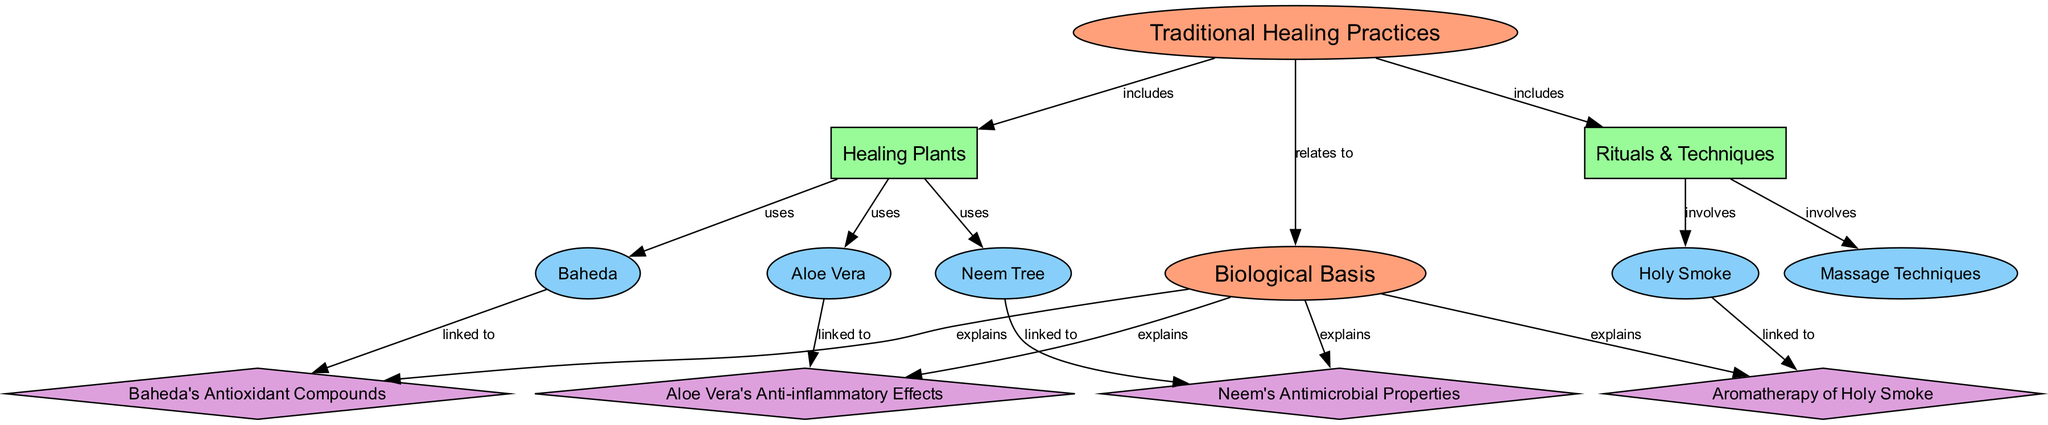What are the core categories of Traditional Healing Practices? The diagram shows two main categories under Traditional Healing Practices: Healing Plants and Rituals & Techniques. These categories are labeled as "category" nodes connected to the core "Traditional Healing Practices" node.
Answer: Healing Plants, Rituals & Techniques How many elements are listed under Healing Plants? The diagram connects three specific elements to the Healing Plants category: Neem Tree, Aloe Vera, and Baheda. Therefore, there are three elements corresponding to this category.
Answer: 3 Which element is linked to Neem's Antimicrobial Properties? The diagram indicates that the Neem Tree element has a direct link to the biological basis known as Neem's Antimicrobial Properties. This connection is represented by an edge labeled "linked to."
Answer: Neem Tree What biological basis is associated with Aloe Vera? According to the diagram, Aloe Vera is linked to Aloe Vera's Anti-inflammatory Effects, indicating its biological basis that explains its healing properties. This connection can be found in the "linked to" edge between the Aloe Vera and its corresponding biological effect.
Answer: Aloe Vera's Anti-inflammatory Effects Which Ritual techniques involve the Holy Smoke? The diagram shows that under the category of Rituals & Techniques, Holy Smoke is linked with aromatherapy in a "linked to" edge. This connection signifies that Holy Smoke is part of the techniques and its biological basis is related to aromatherapy.
Answer: Aromatherapy of Holy Smoke What is the total number of biological bases identified in the diagram? Counting the biological bases connected to the elements returns four unique biological bases: Neem's Antimicrobial Properties, Aloe Vera's Anti-inflammatory Effects, Baheda's Antioxidant Compounds, and Aromatherapy of Holy Smoke.
Answer: 4 What is the relationship between Healing Plants and Biological Basis? The diagram illustrates that Healing Plants indirectly relates to Biological Basis through the linkage of various healing plants to their respective biological properties. Thus, the relationship is that Healing Plants provide resources that have specific biological bases.
Answer: relates to Which technique involves massage? The diagram connects the Massage Techniques element under Rituals & Techniques, indicating that this specific healing technique is part of the broader category of traditional practices.
Answer: Massage Techniques 